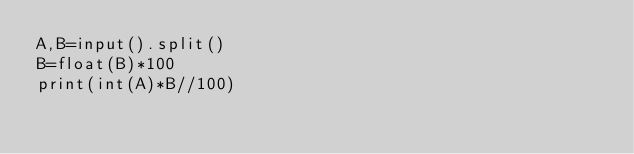<code> <loc_0><loc_0><loc_500><loc_500><_Python_>A,B=input().split()
B=float(B)*100
print(int(A)*B//100)</code> 